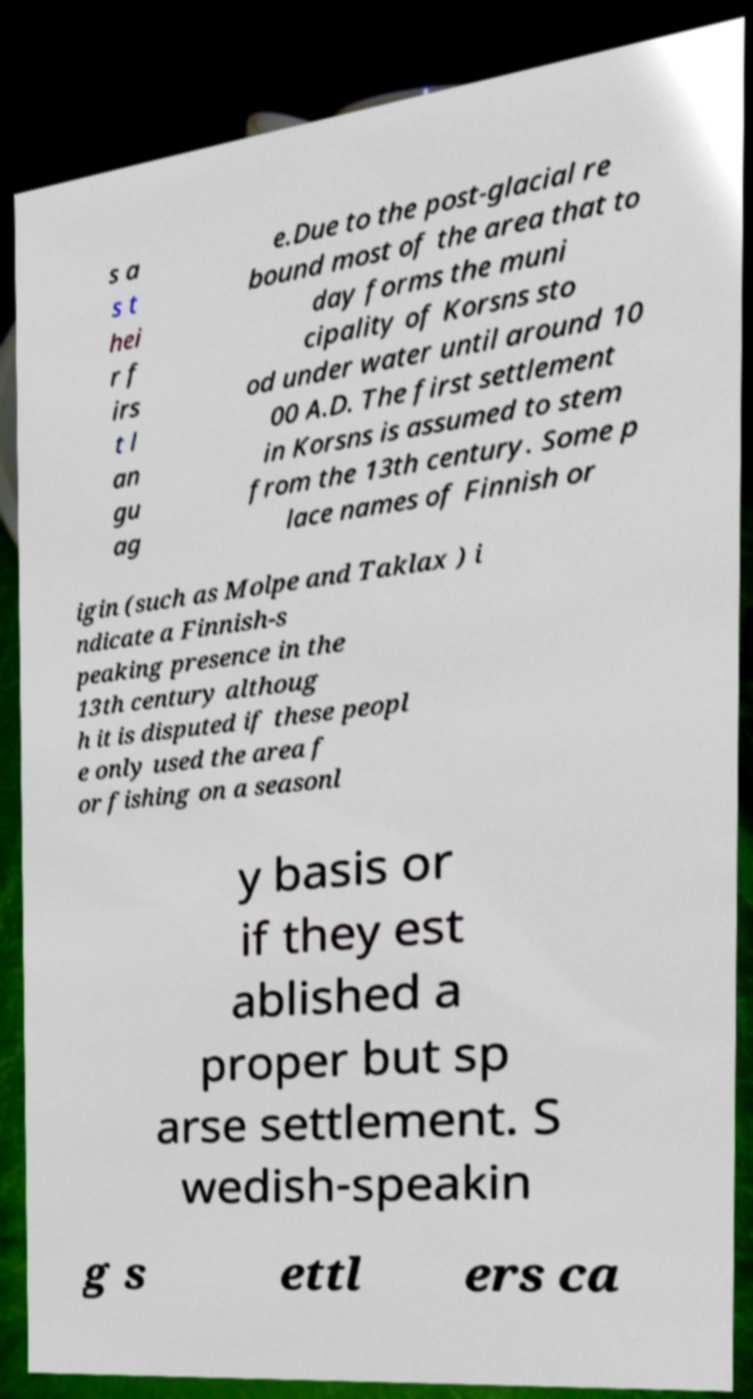Could you assist in decoding the text presented in this image and type it out clearly? s a s t hei r f irs t l an gu ag e.Due to the post-glacial re bound most of the area that to day forms the muni cipality of Korsns sto od under water until around 10 00 A.D. The first settlement in Korsns is assumed to stem from the 13th century. Some p lace names of Finnish or igin (such as Molpe and Taklax ) i ndicate a Finnish-s peaking presence in the 13th century althoug h it is disputed if these peopl e only used the area f or fishing on a seasonl y basis or if they est ablished a proper but sp arse settlement. S wedish-speakin g s ettl ers ca 